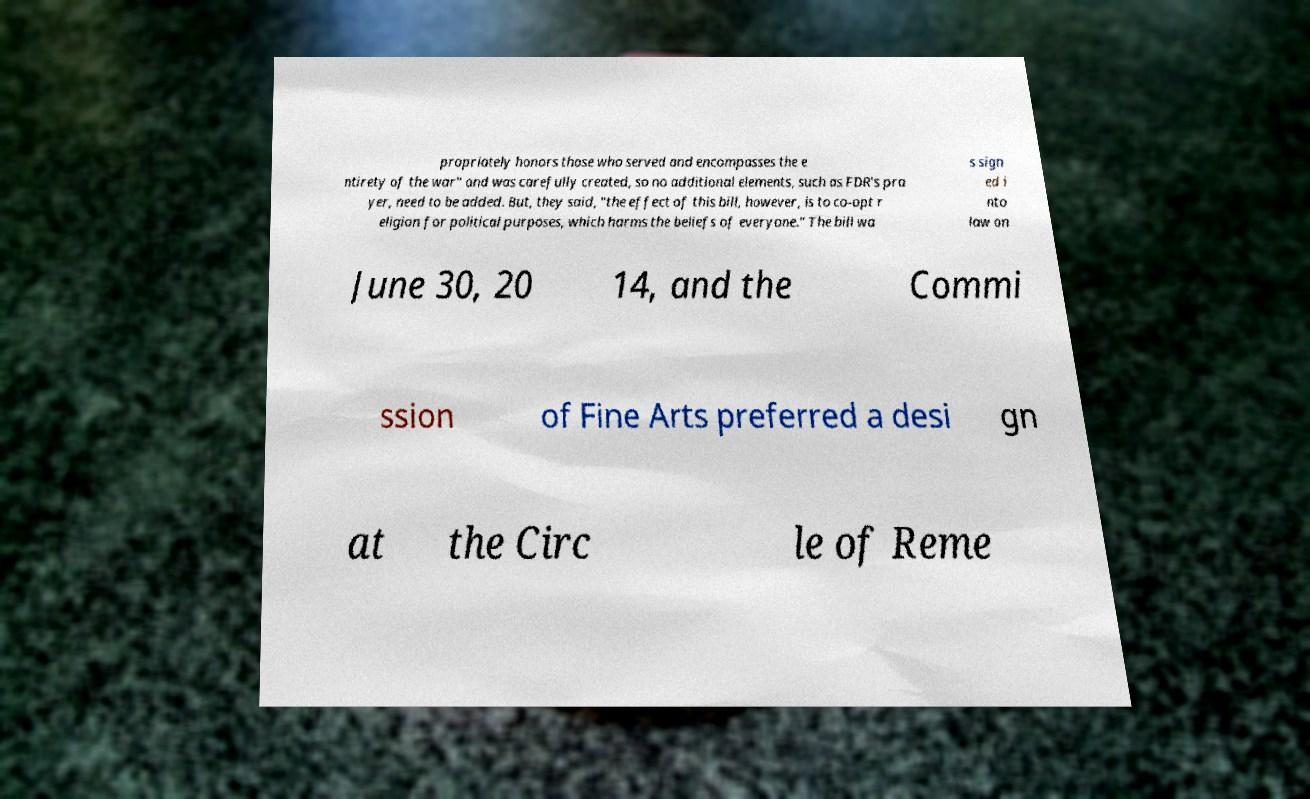What messages or text are displayed in this image? I need them in a readable, typed format. propriately honors those who served and encompasses the e ntirety of the war" and was carefully created, so no additional elements, such as FDR's pra yer, need to be added. But, they said, "the effect of this bill, however, is to co-opt r eligion for political purposes, which harms the beliefs of everyone." The bill wa s sign ed i nto law on June 30, 20 14, and the Commi ssion of Fine Arts preferred a desi gn at the Circ le of Reme 